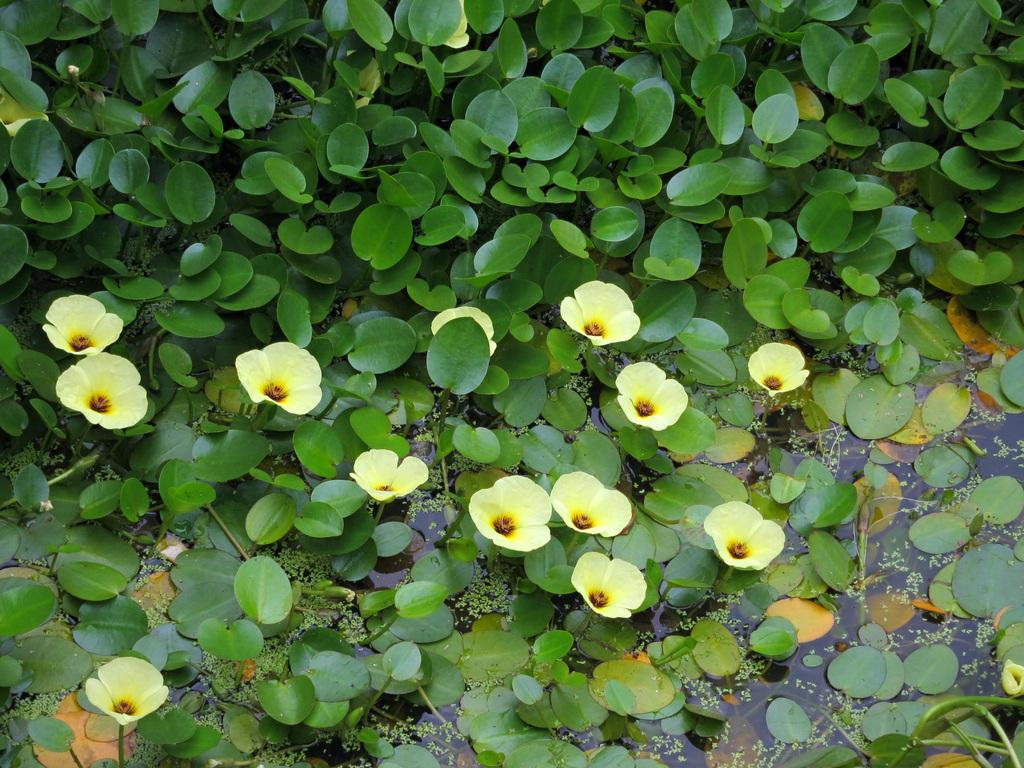What type of flowers can be seen in the foreground of the image? There are yellow colored flowers in the foreground of the image. What are the flowers growing on? The flowers are on plants. How are the plants situated in the image? There are plants on the water in the image. What type of cap is the owl wearing in the image? There is no owl or cap present in the image. 